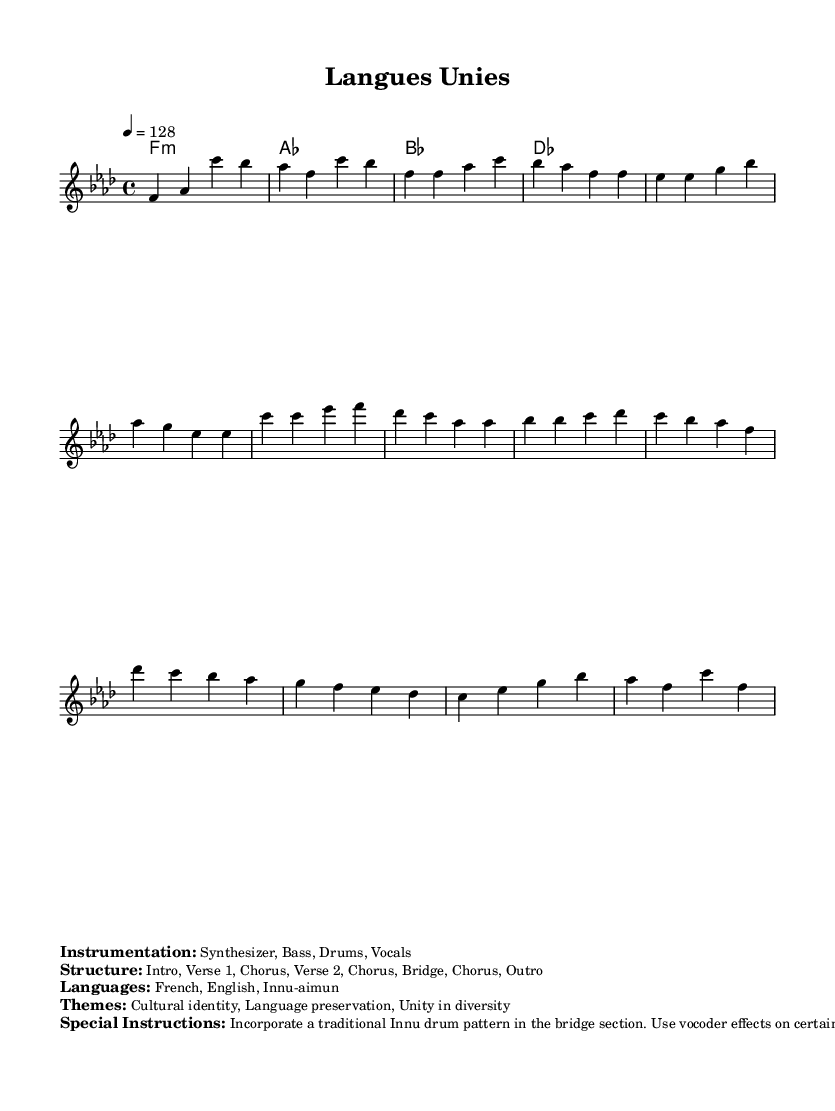What is the key signature of this music? The key signature is indicated in the global section as F minor, which consists of four flats.
Answer: F minor What is the time signature of the piece? The time signature is displayed as 4/4 in the global section, meaning there are four beats per measure and the quarter note gets one beat.
Answer: 4/4 What is the tempo marking of the piece? The tempo is specified in the global section as "4 = 128", indicating a speed of 128 beats per minute.
Answer: 128 How many sections are in the structure? The structure lists eight components: Intro, Verse 1, Chorus, Verse 2, Chorus, Bridge, Chorus, and Outro, totaling eight sections.
Answer: 8 What languages are represented in the music? The languages noted in the markup section are French, English, and Innu-aimun, highlighting the multilingual aspect of the track.
Answer: French, English, Innu-aimun What theme is emphasized in this piece? The themes are explicitly stated in the markup as cultural identity, language preservation, and unity in diversity, reflecting the music's focus on these concepts.
Answer: Cultural identity What type of instrumentation is used? The instrumentation is detailed in the markup as synthesizer, bass, drums, and vocals, indicating the electronic and vocal elements utilized in the track.
Answer: Synthesizer, Bass, Drums, Vocals 